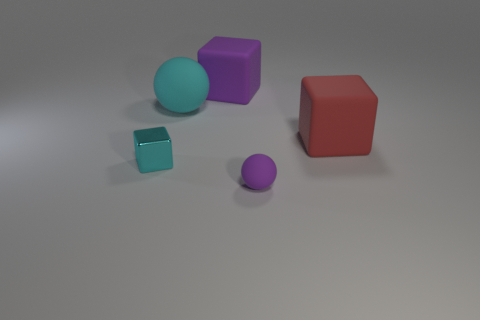Add 1 big purple rubber blocks. How many objects exist? 6 Subtract all cubes. How many objects are left? 2 Subtract all big yellow matte cubes. Subtract all tiny metal cubes. How many objects are left? 4 Add 4 big purple rubber things. How many big purple rubber things are left? 5 Add 4 large objects. How many large objects exist? 7 Subtract 1 cyan blocks. How many objects are left? 4 